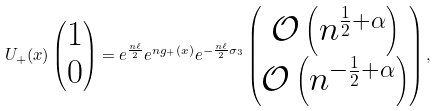<formula> <loc_0><loc_0><loc_500><loc_500>U _ { + } ( x ) \begin{pmatrix} 1 \\ 0 \end{pmatrix} = e ^ { \frac { n \ell } { 2 } } e ^ { n g _ { + } ( x ) } e ^ { - \frac { n \ell } { 2 } \sigma _ { 3 } } \begin{pmatrix} \mathcal { O } \left ( n ^ { \frac { 1 } { 2 } + \alpha } \right ) \\ \mathcal { O } \left ( n ^ { - \frac { 1 } { 2 } + \alpha } \right ) \end{pmatrix} ,</formula> 